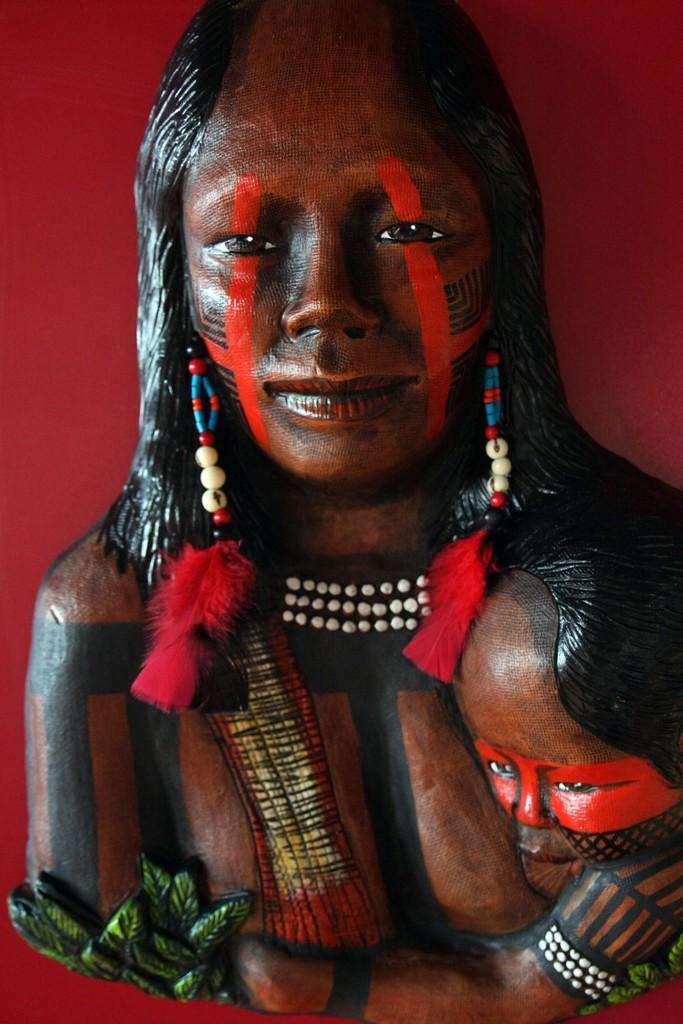What is the main subject of the image? There is a sculpture of a woman and a child in the image. Are there any accessories or additional items in the image? Yes, there is a necklace in the image. What type of natural elements can be seen in the image? There are leaves in the image. What color is the background of the image? The background appears to be maroon in color. How many oranges are on the goose in the image? There is no goose or oranges present in the image. What type of jar is visible in the image? There is no jar present in the image. 